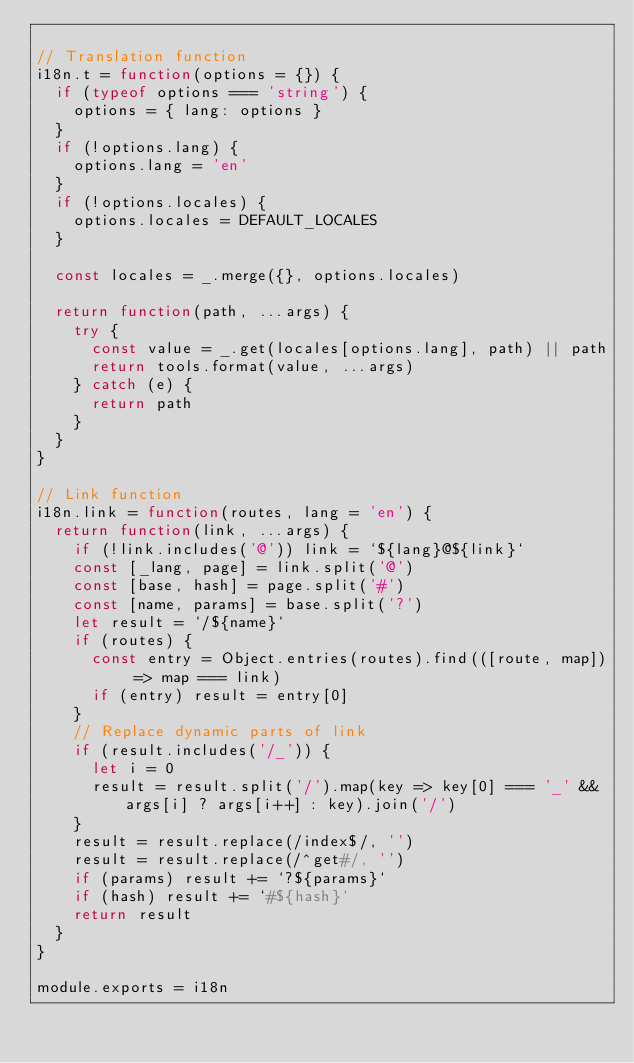Convert code to text. <code><loc_0><loc_0><loc_500><loc_500><_JavaScript_>
// Translation function
i18n.t = function(options = {}) {
  if (typeof options === 'string') {
    options = { lang: options }
  }
  if (!options.lang) {
    options.lang = 'en'
  }
  if (!options.locales) {
    options.locales = DEFAULT_LOCALES
  }

  const locales = _.merge({}, options.locales)

  return function(path, ...args) {
    try {
      const value = _.get(locales[options.lang], path) || path
      return tools.format(value, ...args)
    } catch (e) {
      return path
    }
  }
}

// Link function
i18n.link = function(routes, lang = 'en') {
  return function(link, ...args) {
    if (!link.includes('@')) link = `${lang}@${link}`
    const [_lang, page] = link.split('@')
    const [base, hash] = page.split('#')
    const [name, params] = base.split('?')
    let result = `/${name}`
    if (routes) {
      const entry = Object.entries(routes).find(([route, map]) => map === link)
      if (entry) result = entry[0]
    }
    // Replace dynamic parts of link
    if (result.includes('/_')) {
      let i = 0
      result = result.split('/').map(key => key[0] === '_' && args[i] ? args[i++] : key).join('/')
    }
    result = result.replace(/index$/, '')
    result = result.replace(/^get#/, '')
    if (params) result += `?${params}`
    if (hash) result += `#${hash}`
    return result
  }
}

module.exports = i18n
</code> 